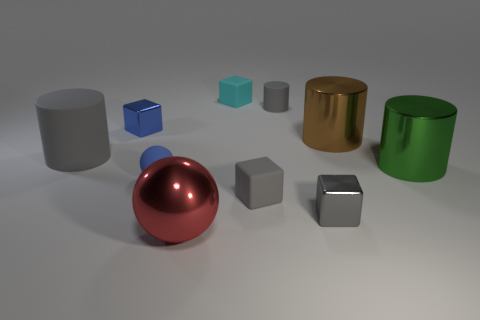Subtract all tiny gray rubber blocks. How many blocks are left? 3 Subtract all cyan blocks. How many blocks are left? 3 Subtract all brown balls. How many gray cylinders are left? 2 Subtract all balls. How many objects are left? 8 Add 7 brown rubber blocks. How many brown rubber blocks exist? 7 Subtract 0 green blocks. How many objects are left? 10 Subtract 1 cylinders. How many cylinders are left? 3 Subtract all purple spheres. Subtract all red blocks. How many spheres are left? 2 Subtract all big blue objects. Subtract all tiny gray cylinders. How many objects are left? 9 Add 3 big gray things. How many big gray things are left? 4 